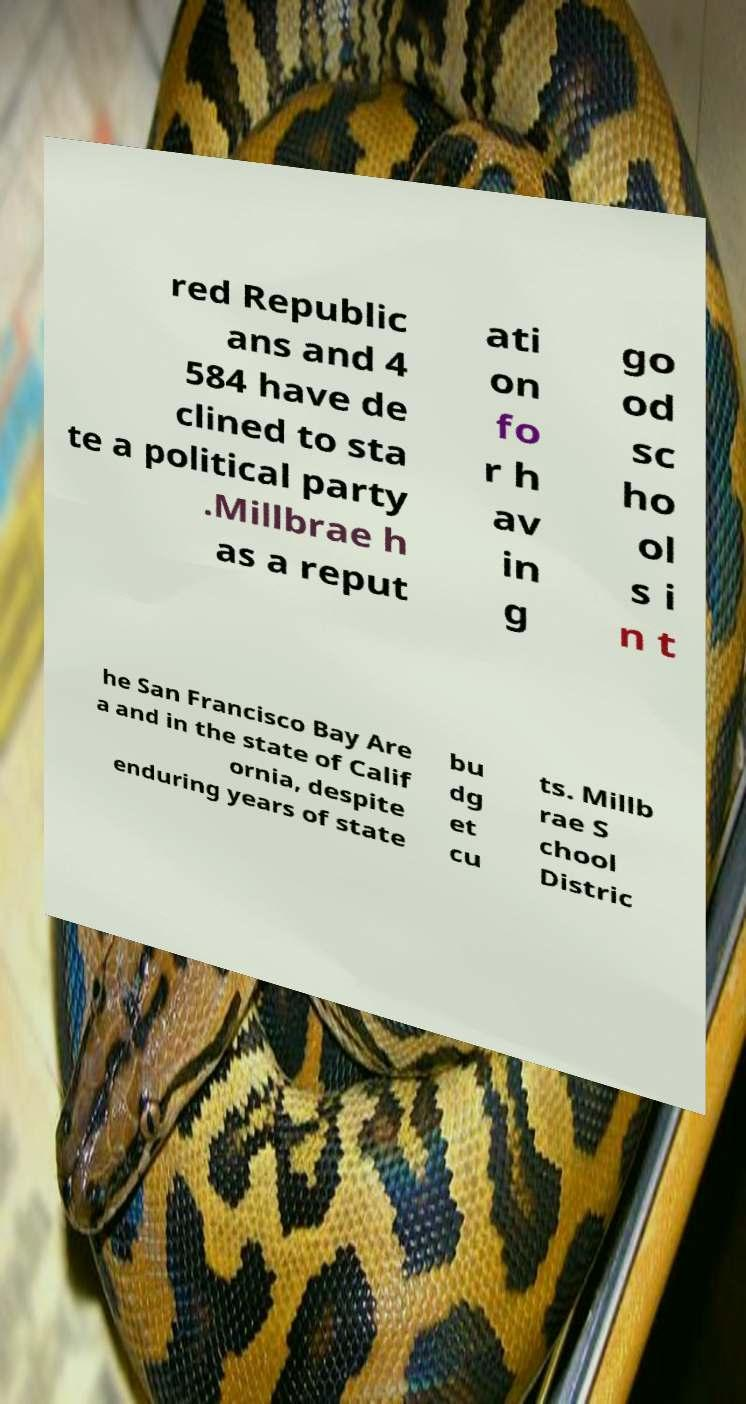I need the written content from this picture converted into text. Can you do that? red Republic ans and 4 584 have de clined to sta te a political party .Millbrae h as a reput ati on fo r h av in g go od sc ho ol s i n t he San Francisco Bay Are a and in the state of Calif ornia, despite enduring years of state bu dg et cu ts. Millb rae S chool Distric 